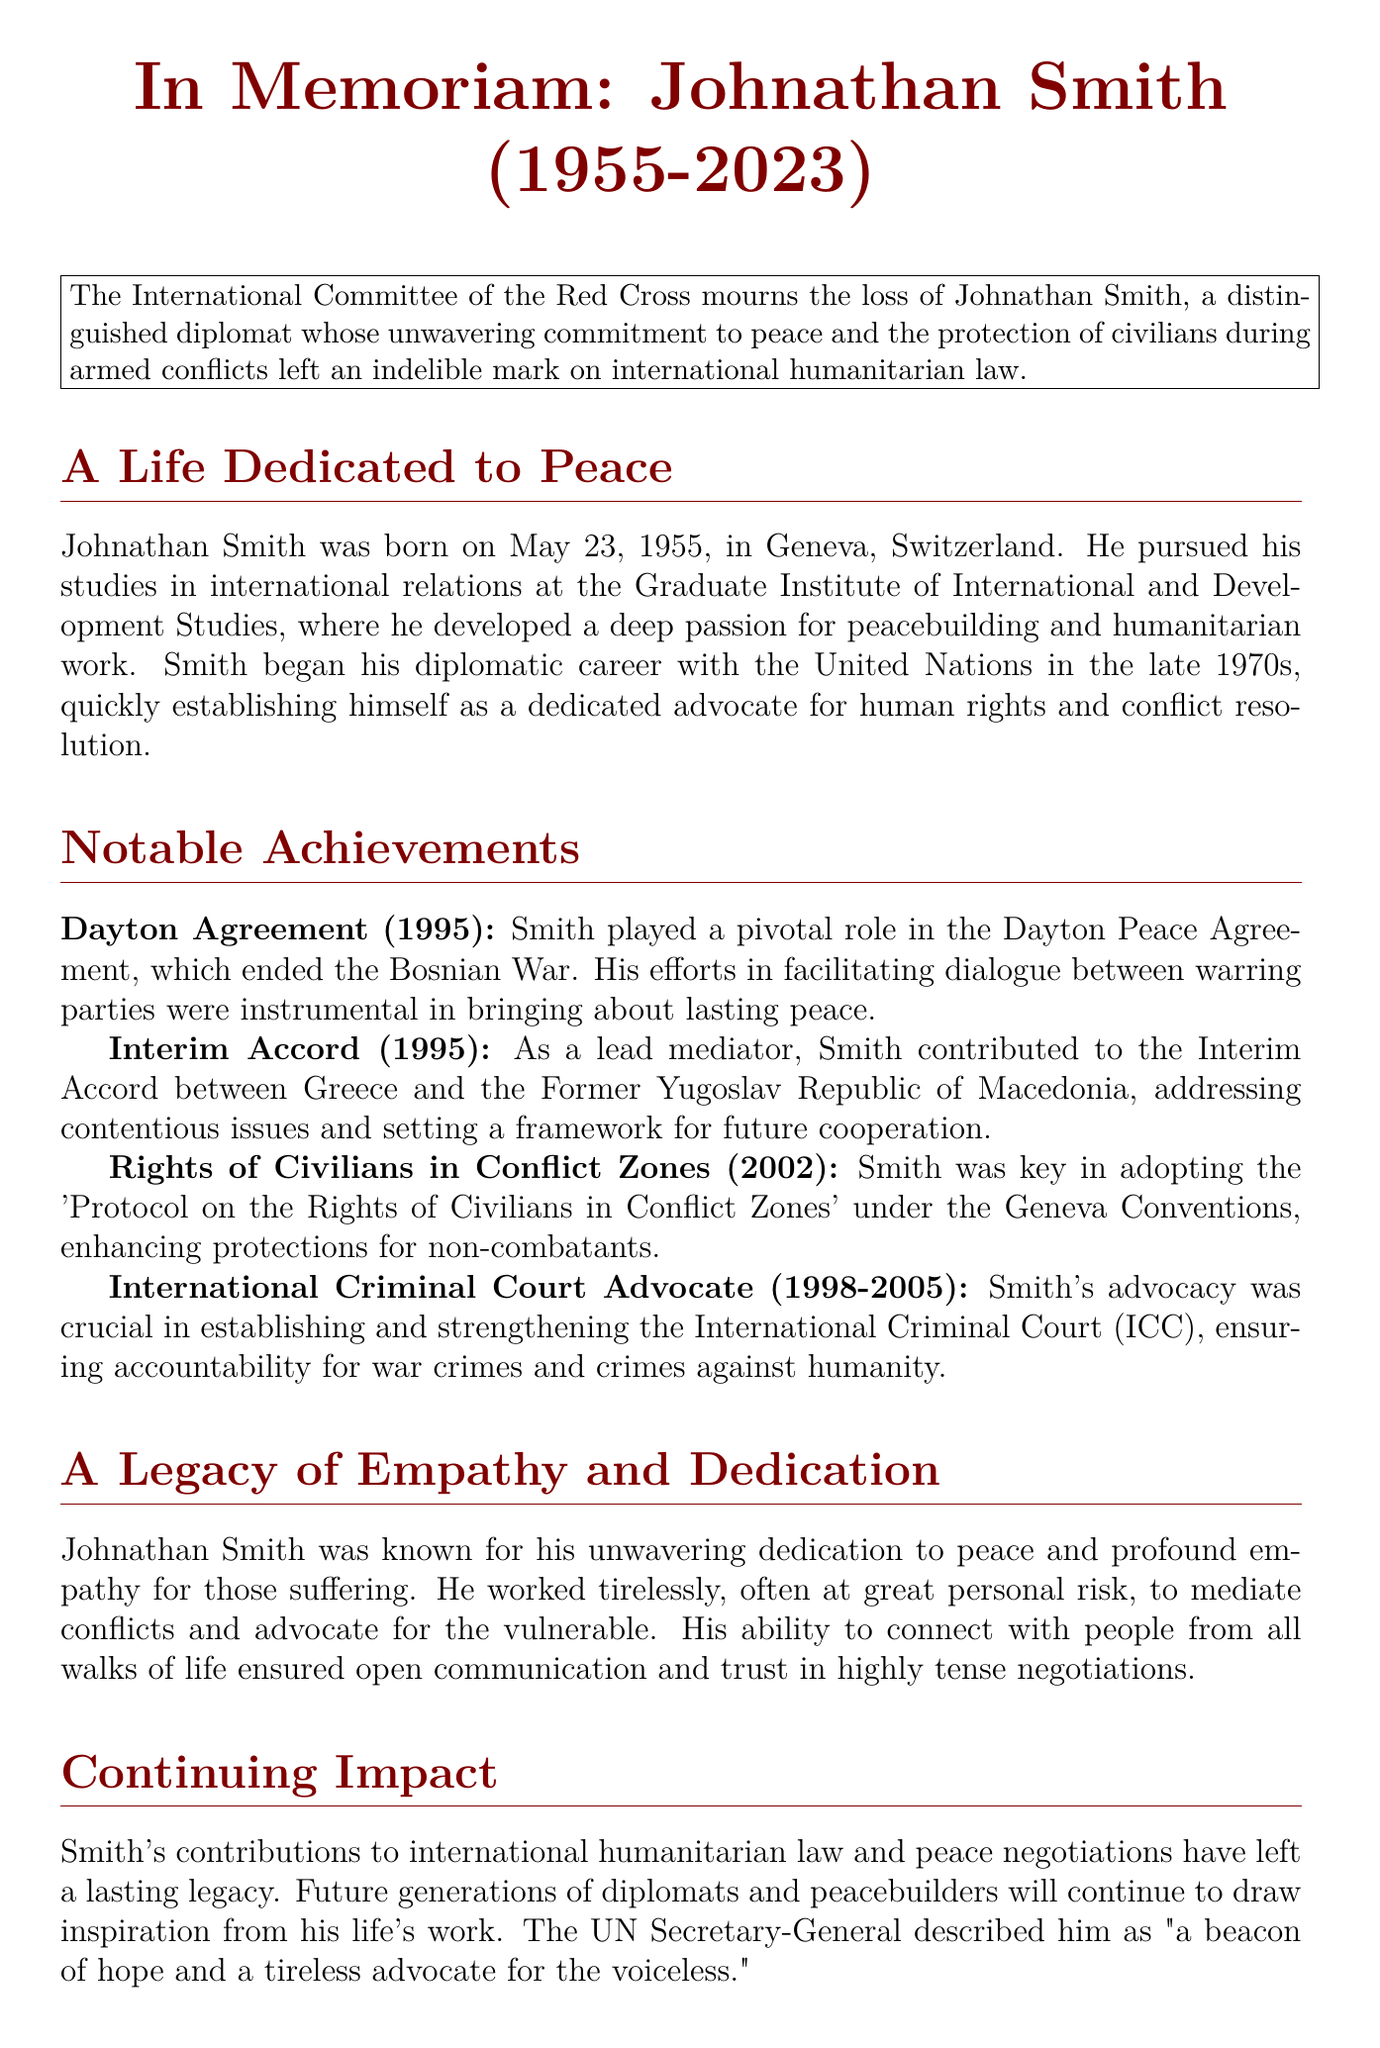What is the full name of the diplomat? The full name of the diplomat is mentioned prominently in the title of the obituary.
Answer: Johnathan Smith What year was Johnathan Smith born? The birth year is provided early in the document within the biography section.
Answer: 1955 Which peace agreement did Smith play a pivotal role in? The significant peace agreement Smith contributed to is listed under notable achievements.
Answer: Dayton Agreement In what year was the 'Protocol on the Rights of Civilians in Conflict Zones' adopted? The year of adoption for the mentioned protocol can be found in the notable achievements section.
Answer: 2002 How long did Smith advocate for the International Criminal Court? The duration of this advocacy is specified in the achievements section of the document.
Answer: 1998-2005 What city was Johnathan Smith born in? The city of birth is indicated early in the obituary under the biography details.
Answer: Geneva What quality was Johnathan Smith known for during negotiations? The document describes one of Smith's notable qualities in mediating discussions.
Answer: Empathy Who described Smith as "a beacon of hope"? The individual who made this statement about Smith is mentioned in the closing remarks of the document.
Answer: UN Secretary-General 